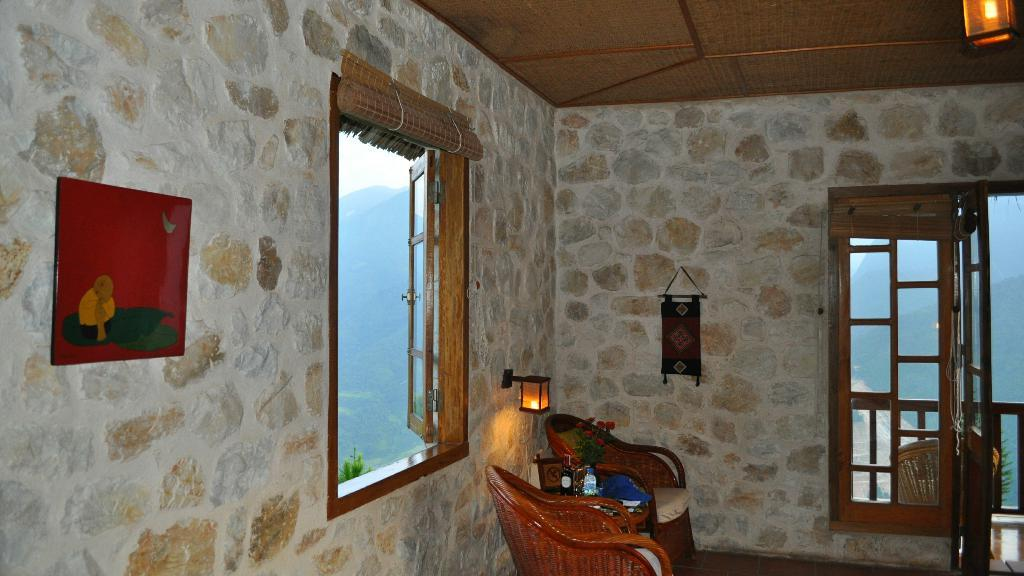What can be seen on the right side of the image? There are windows on the right side of the image. What can be seen on the left side of the image? There are windows on the left side of the image. What type of furniture is visible at the bottom side of the image? There are chairs at the bottom side of the image. What type of wave can be seen crashing against the windows in the image? There is no wave present in the image; it features windows on both sides and chairs at the bottom. 